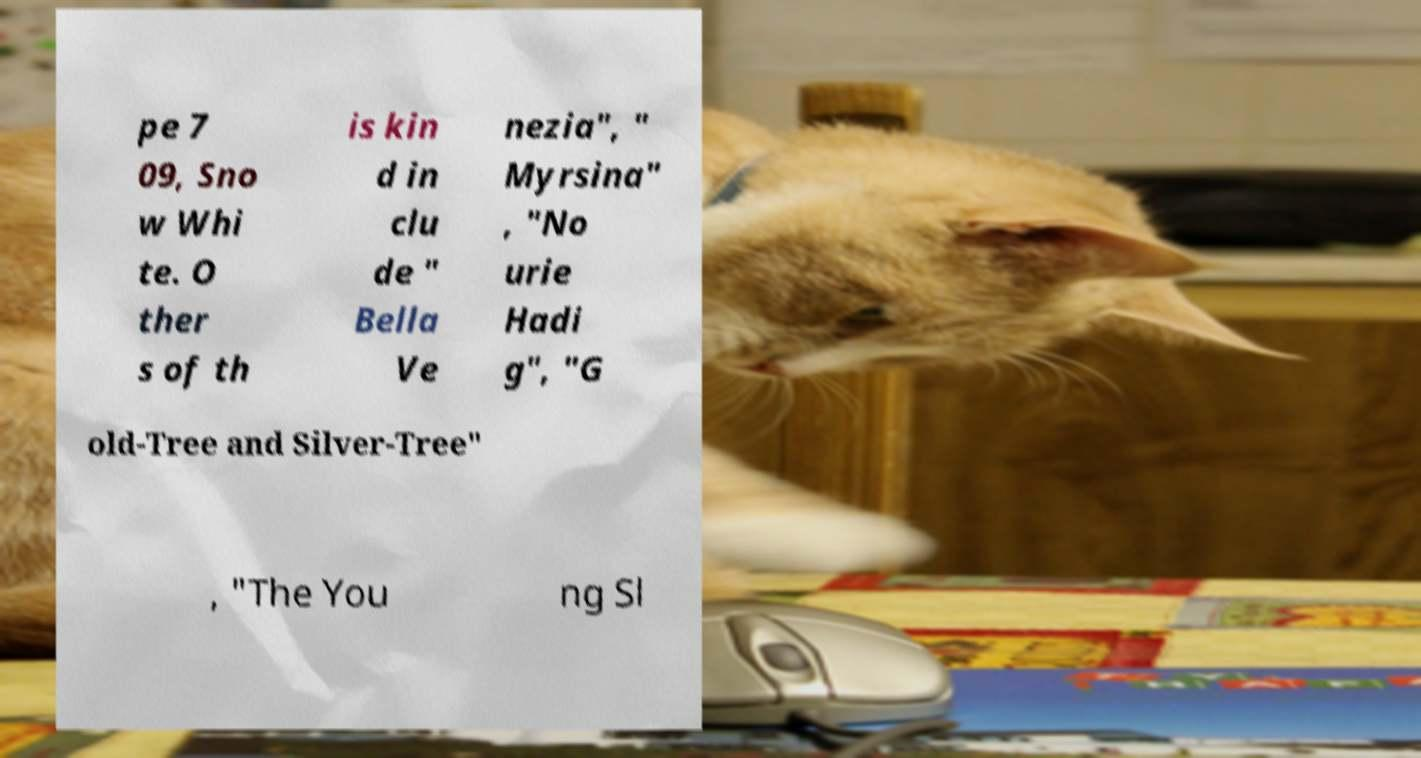Can you read and provide the text displayed in the image?This photo seems to have some interesting text. Can you extract and type it out for me? pe 7 09, Sno w Whi te. O ther s of th is kin d in clu de " Bella Ve nezia", " Myrsina" , "No urie Hadi g", "G old-Tree and Silver-Tree" , "The You ng Sl 